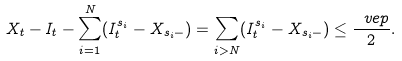Convert formula to latex. <formula><loc_0><loc_0><loc_500><loc_500>X _ { t } - I _ { t } - \sum _ { i = 1 } ^ { N } ( I ^ { s _ { i } } _ { t } - X _ { s _ { i } - } ) = \sum _ { i > N } ( I ^ { s _ { i } } _ { t } - X _ { s _ { i } - } ) \leq \frac { \ v e p } { 2 } .</formula> 